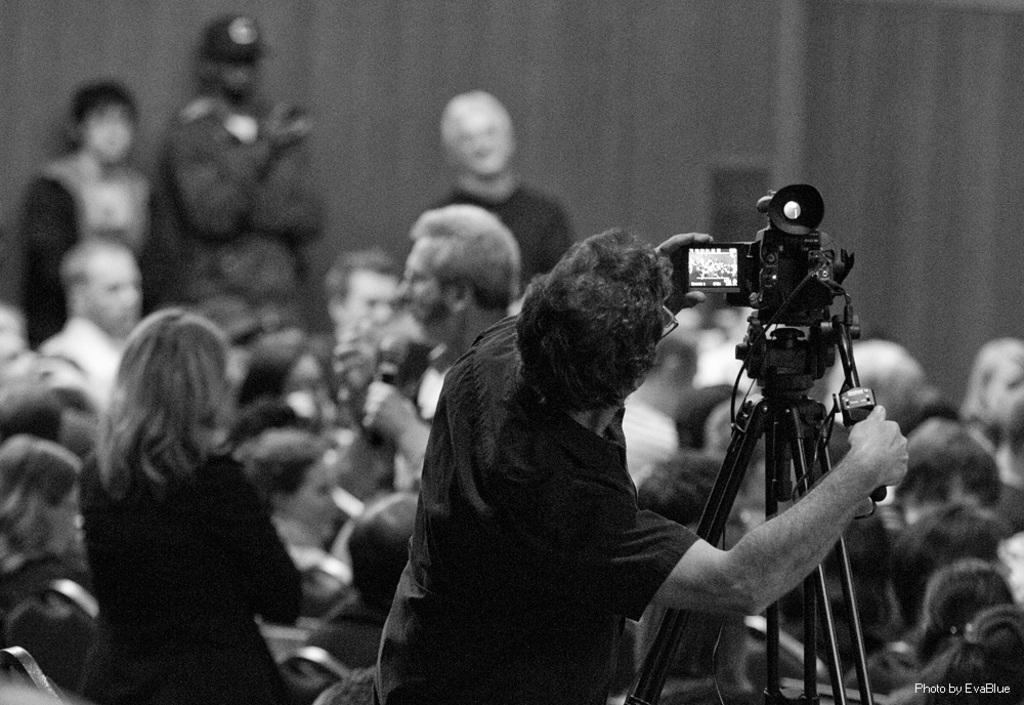What are the people in the image doing? Some people are standing, and some are sitting in the image. Can you describe the camera in the image? There is a camera placed on a stand on the right side of the image. What is visible in the background of the image? There is a wall in the background of the image. Where is the spoon located in the image? There is no spoon present in the image. What type of friends are visible in the image? The image does not depict any friends; it only shows people standing and sitting. 